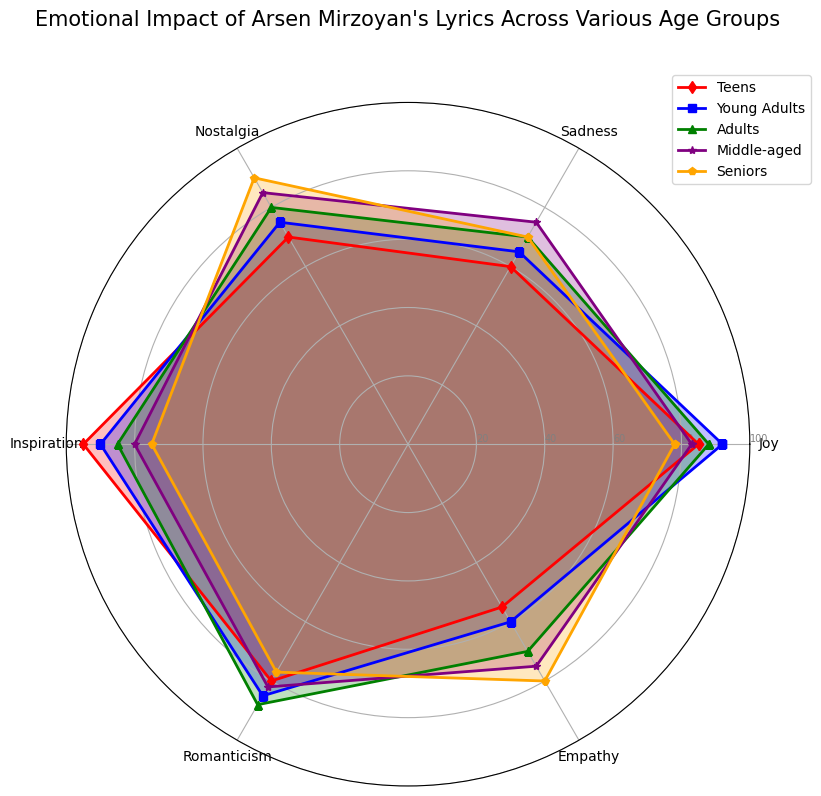What's the highest emotion felt by adults? The figure shows that "Romanticism" has the highest value for adults at 88.
Answer: Romanticism Which age group experiences the most "Inspiration"? According to the figure, teens have the highest value for "Inspiration" at 95.
Answer: Teens What is the average Nostalgia level across all age groups? The values for Nostalgia are 70 (Teens), 75 (Young Adults), 80 (Adults), 85 (Middle-aged), and 90 (Seniors). The sum is 70 + 75 + 80 + 85 + 90 = 400. The average is 400/5 = 80.
Answer: 80 Is the "Joy" experienced by middle-aged individuals higher or lower than seniors? The radar chart shows the "Joy" value for middle-aged is 83 and for seniors is 78. 83 is higher than 78.
Answer: Higher Compare the "Empathy" level of Adults and Teens. Which is higher? Adults have an "Empathy" level of 70, while Teens have 55. Thus, adults have a higher "Empathy" level than teens.
Answer: Adults By how many units is the "Sadness" experienced by seniors higher than the "Sadness" experienced by teens? The "Sadness" level for seniors is 70, and for teens, it is 60. The difference is 70 - 60 = 10 units.
Answer: 10 Which color represents the group that feels the strongest "Romanticism"? The radar chart uses colors to distinguish groups, and "Young Adults" feel the strongest "Romanticism" at 85. Young Adults are represented by blue.
Answer: Blue In which emotional aspect do Seniors show the highest value? The radar chart indicates that Seniors show their highest value in "Nostalgia" at 90.
Answer: Nostalgia What's the difference between the highest and lowest values of "Empathy"? The highest "Empathy" value is 80 (Seniors), and the lowest is 55 (Teens). The difference is 80 - 55 = 25.
Answer: 25 